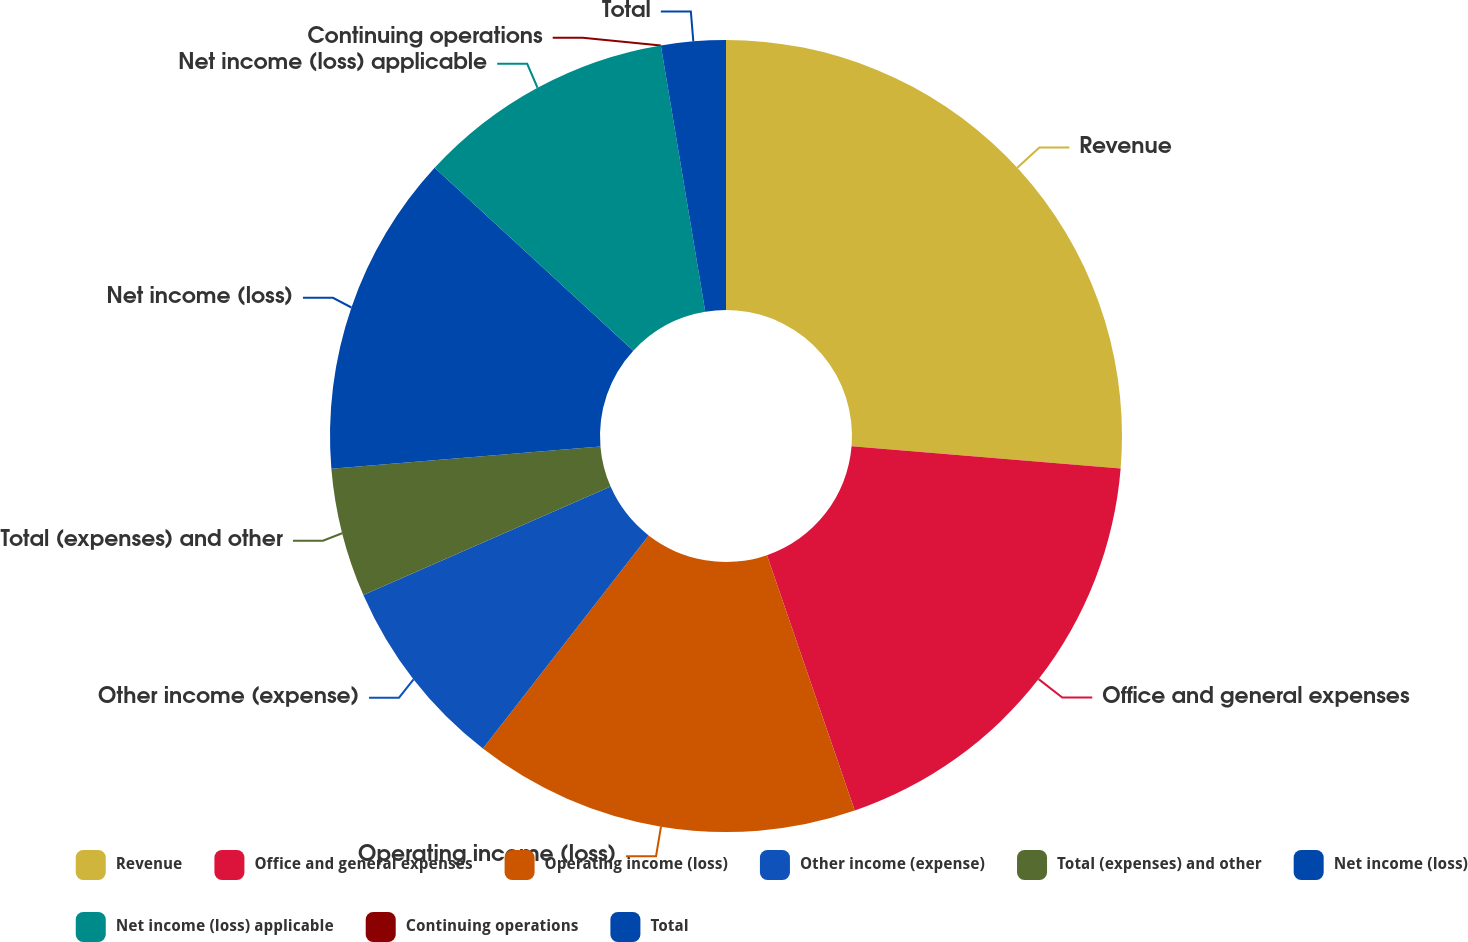<chart> <loc_0><loc_0><loc_500><loc_500><pie_chart><fcel>Revenue<fcel>Office and general expenses<fcel>Operating income (loss)<fcel>Other income (expense)<fcel>Total (expenses) and other<fcel>Net income (loss)<fcel>Net income (loss) applicable<fcel>Continuing operations<fcel>Total<nl><fcel>26.31%<fcel>18.42%<fcel>15.79%<fcel>7.9%<fcel>5.26%<fcel>13.16%<fcel>10.53%<fcel>0.0%<fcel>2.63%<nl></chart> 